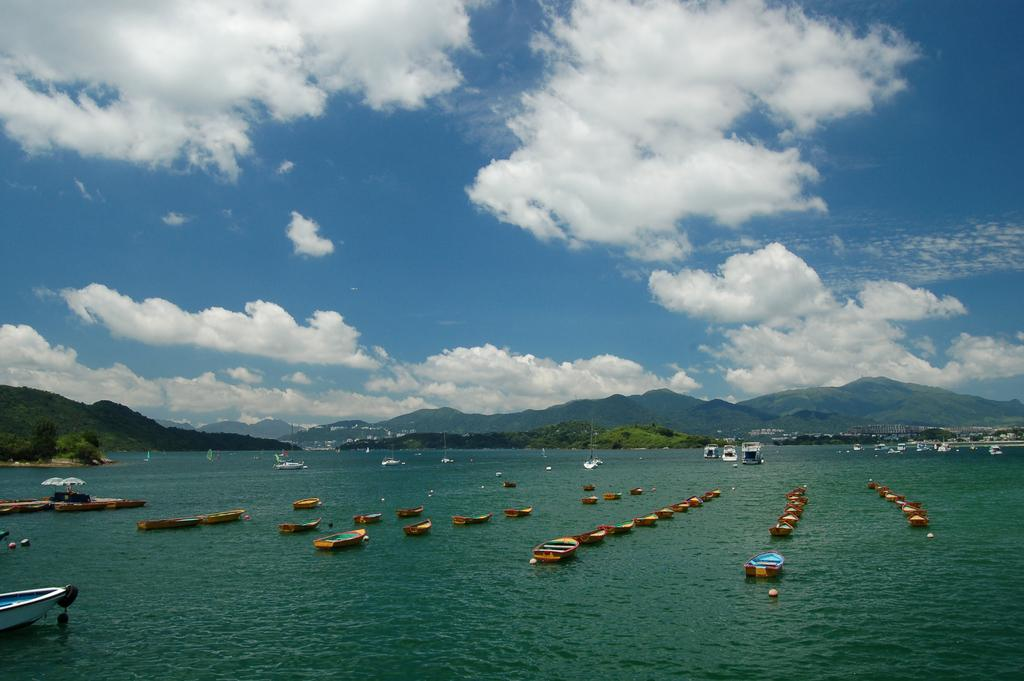What types of watercraft are in the image? There are boats and ships in the image. Where are the boats and ships located? The boats and ships are on the water in the image. What type of natural landscape can be seen in the image? There are hills visible in the image. What type of vegetation is present in the image? There are trees in the image. What type of shade provider is present in the image? There are parasols in the image. What is visible in the sky in the image? The sky is visible in the image, and there are clouds in the sky. Where is the grandfather standing in the image? There is no grandfather present in the image. How many people are in the crowd in the image? There is no crowd present in the image. What type of cooking utensil is visible in the image? There is no cooking utensil, such as a pan, present in the image. 